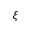<formula> <loc_0><loc_0><loc_500><loc_500>\xi</formula> 